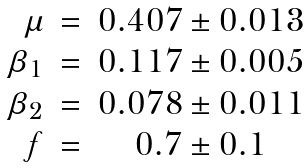<formula> <loc_0><loc_0><loc_500><loc_500>\begin{array} { r c c } \mu & = & 0 . 4 0 7 \pm 0 . 0 1 3 \\ \beta _ { 1 } & = & 0 . 1 1 7 \pm 0 . 0 0 5 \\ \beta _ { 2 } & = & 0 . 0 7 8 \pm 0 . 0 1 1 \\ f & = & 0 . 7 \pm 0 . 1 \\ \end{array}</formula> 